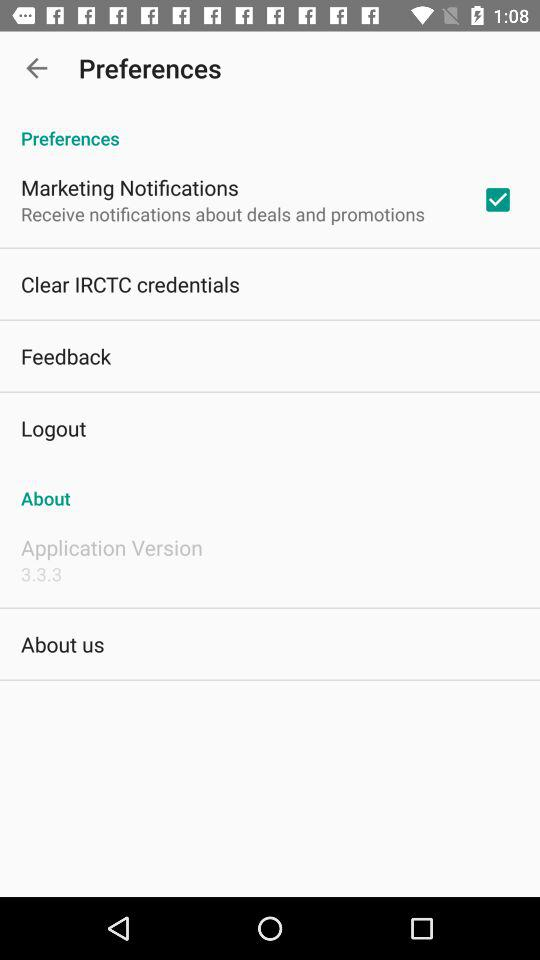What is the version number? The version number is 3.3.3. 